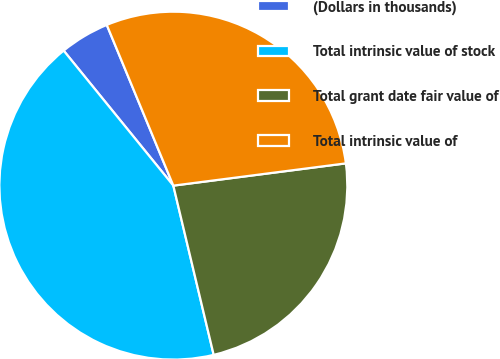Convert chart to OTSL. <chart><loc_0><loc_0><loc_500><loc_500><pie_chart><fcel>(Dollars in thousands)<fcel>Total intrinsic value of stock<fcel>Total grant date fair value of<fcel>Total intrinsic value of<nl><fcel>4.61%<fcel>42.87%<fcel>23.32%<fcel>29.21%<nl></chart> 